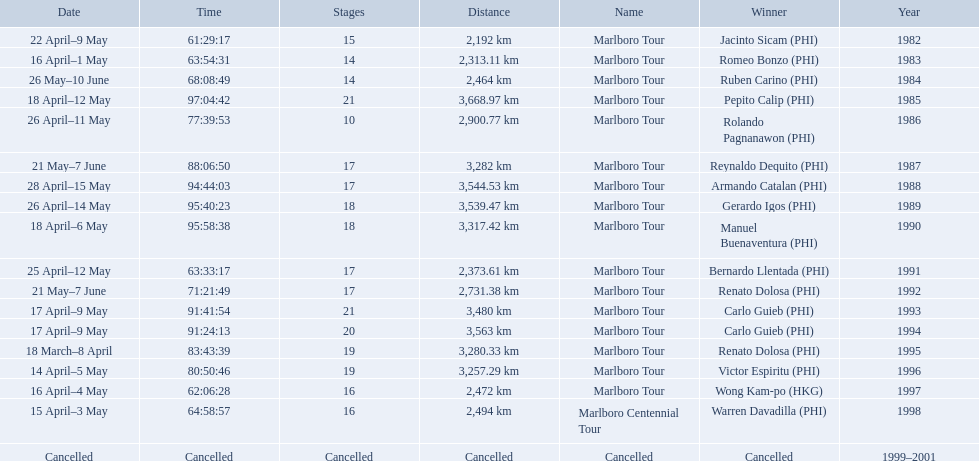What are the distances travelled on the tour? 2,192 km, 2,313.11 km, 2,464 km, 3,668.97 km, 2,900.77 km, 3,282 km, 3,544.53 km, 3,539.47 km, 3,317.42 km, 2,373.61 km, 2,731.38 km, 3,480 km, 3,563 km, 3,280.33 km, 3,257.29 km, 2,472 km, 2,494 km. Which of these are the largest? 3,668.97 km. 